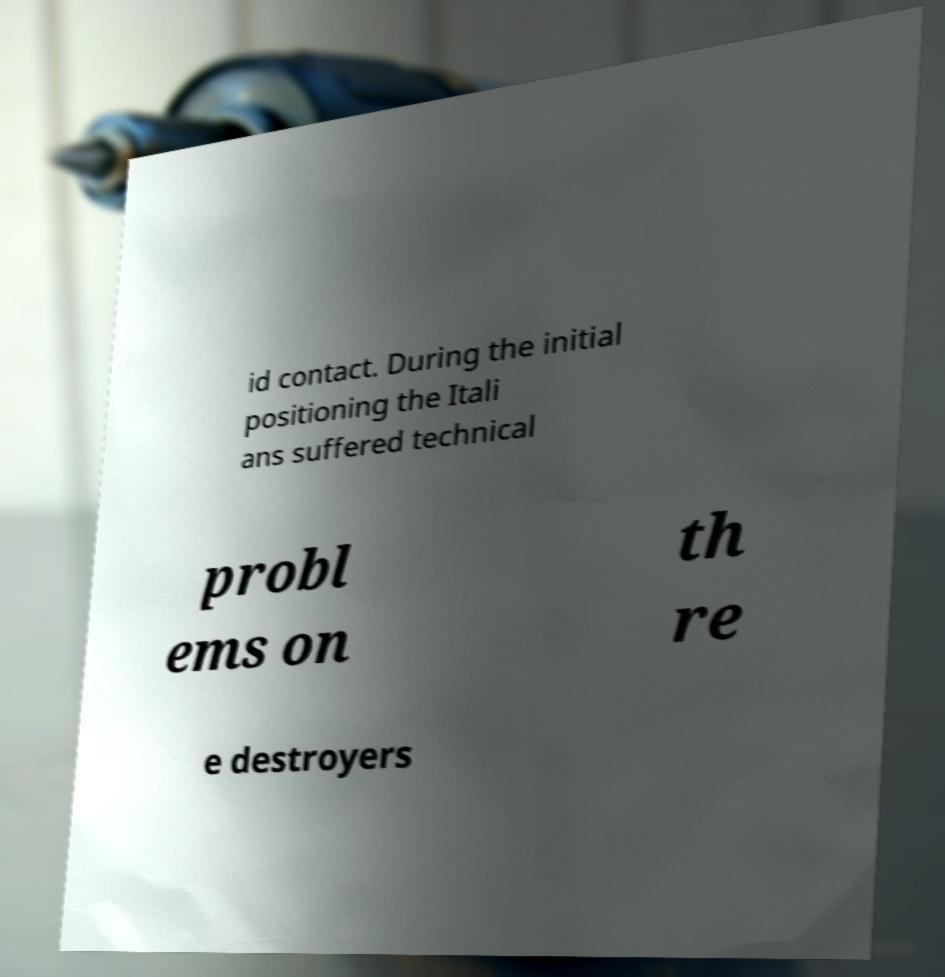Can you accurately transcribe the text from the provided image for me? id contact. During the initial positioning the Itali ans suffered technical probl ems on th re e destroyers 